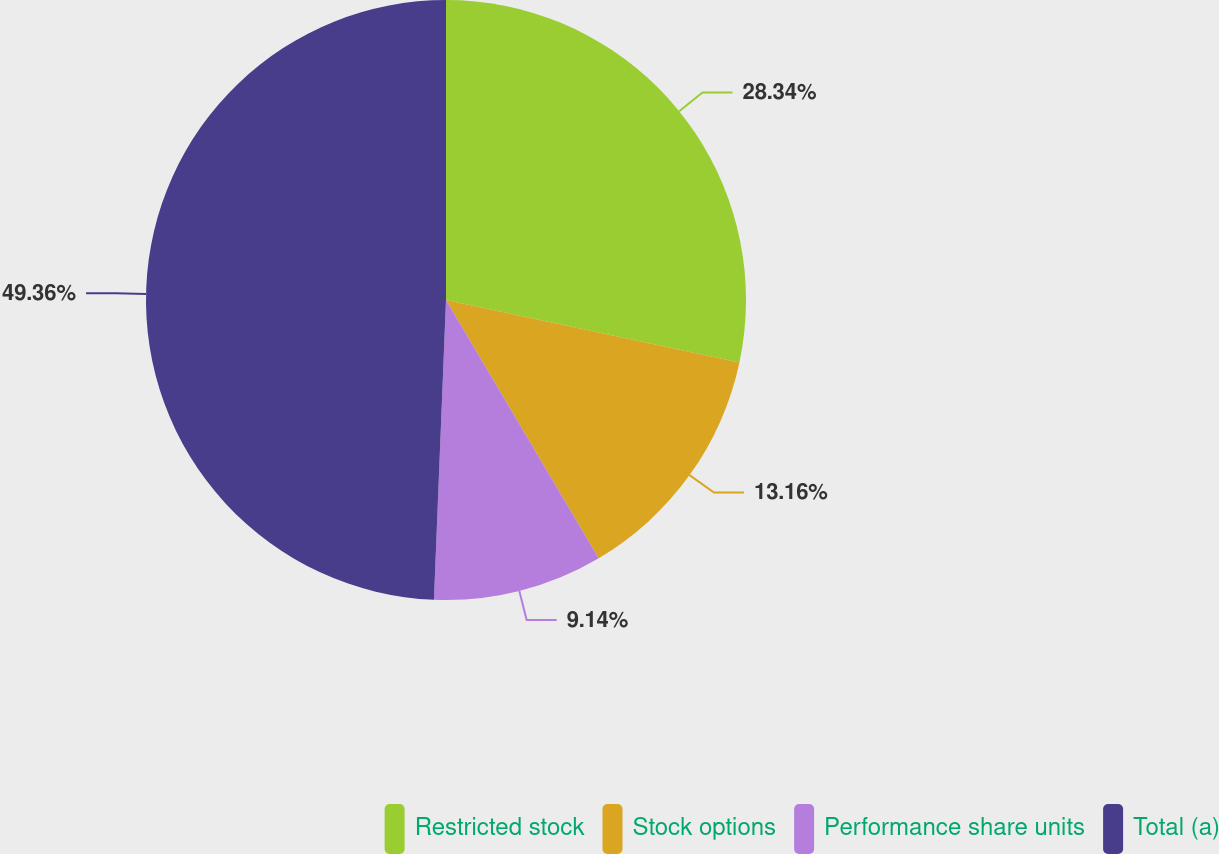Convert chart to OTSL. <chart><loc_0><loc_0><loc_500><loc_500><pie_chart><fcel>Restricted stock<fcel>Stock options<fcel>Performance share units<fcel>Total (a)<nl><fcel>28.34%<fcel>13.16%<fcel>9.14%<fcel>49.36%<nl></chart> 